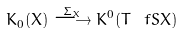<formula> <loc_0><loc_0><loc_500><loc_500>K _ { 0 } ( X ) \overset { \Sigma _ { X } } { \longrightarrow } K ^ { 0 } ( T ^ { \ } f S X )</formula> 